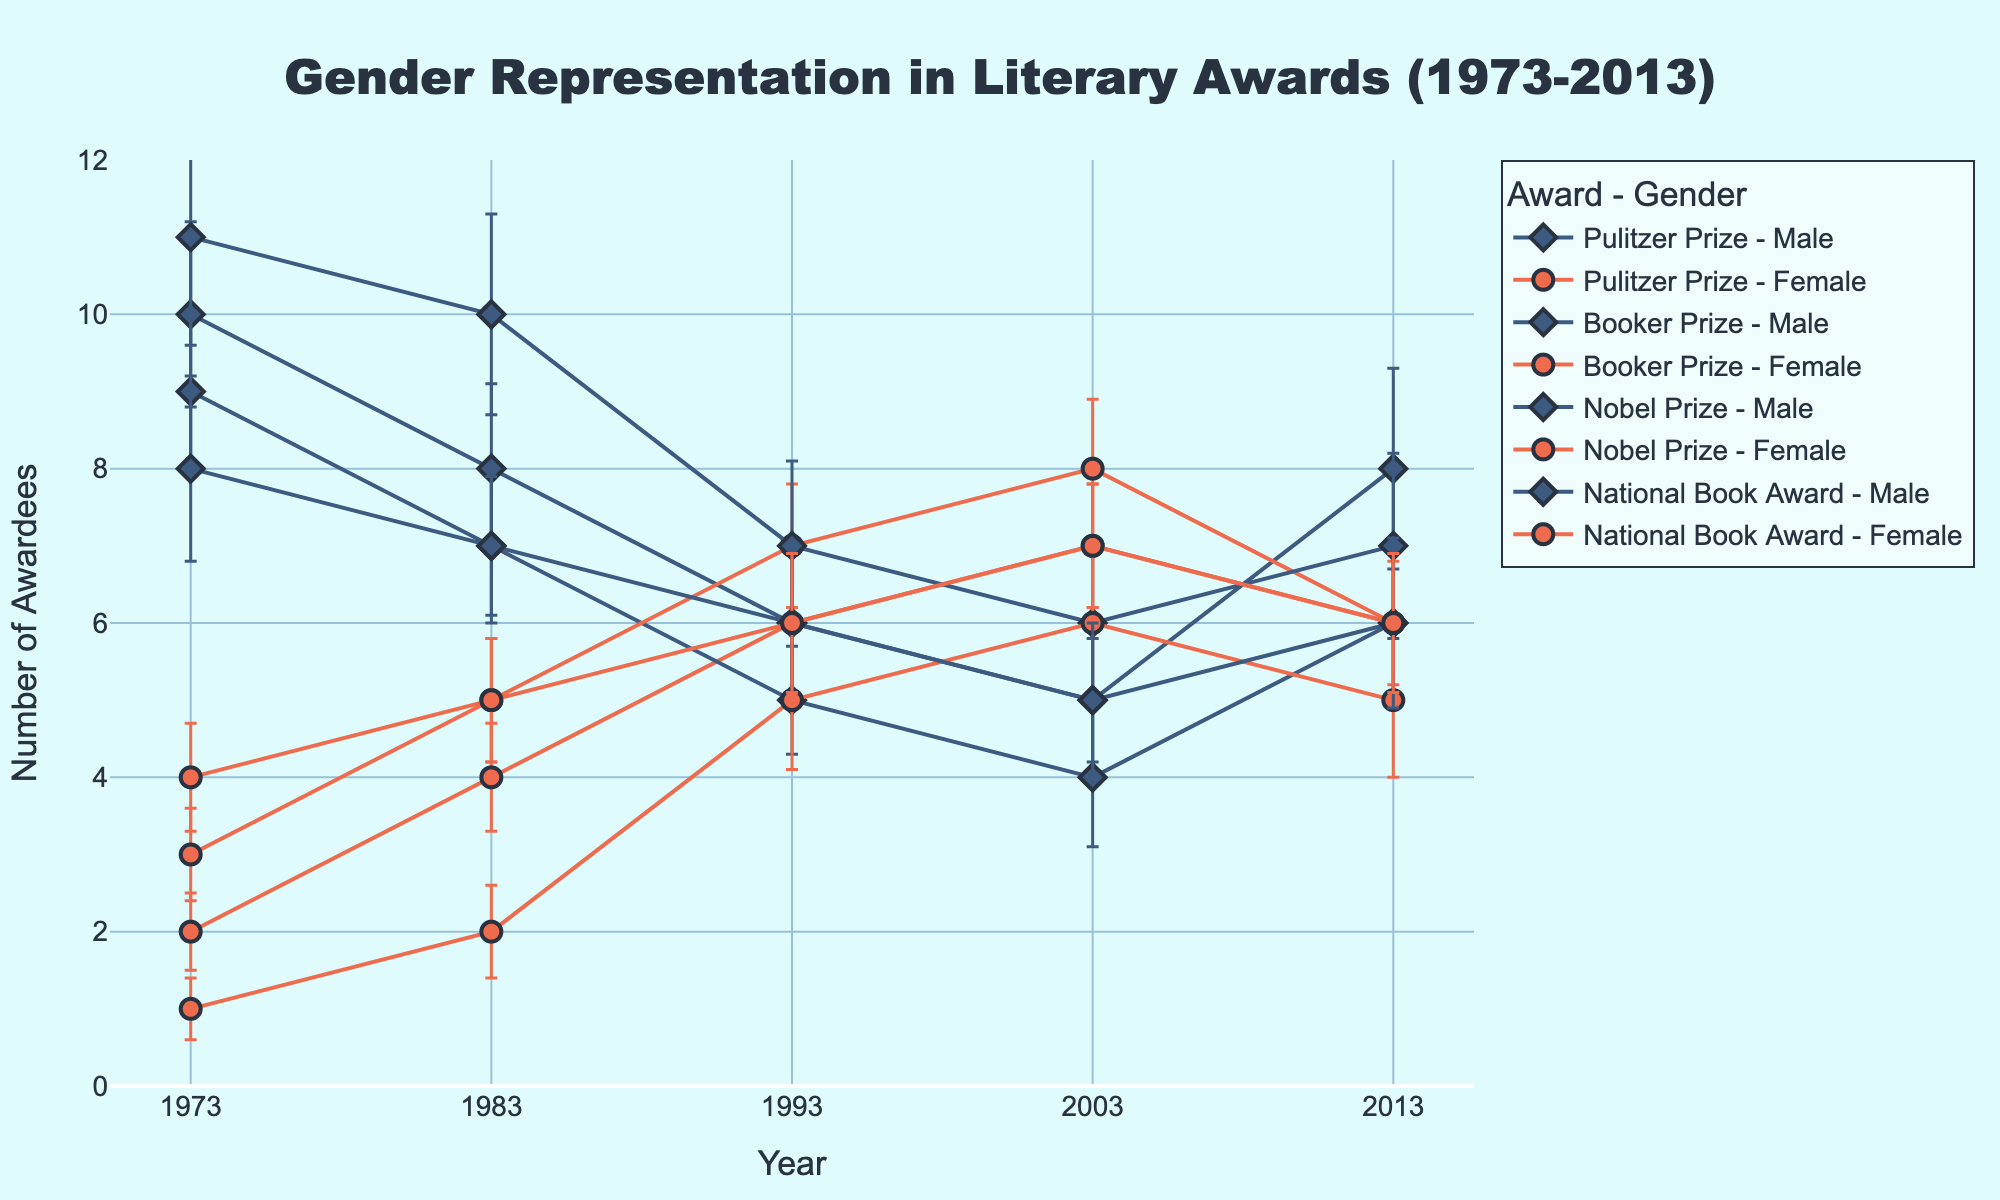What is the title of the figure? The title is generally located at the top of the figure and is intended to describe the content and purpose of the figure. The given figure's title describes the focus on gender representation within literary awards over a 40-year span.
Answer: Gender Representation in Literary Awards (1973-2013) How many different literary awards are represented in the figure? We can count the distinct award names listed in the legend or by looking at the information provided in the data. Each award will appear in both male and female categories.
Answer: 4 What is the color used to represent male awardees? Look for any legend or color labels that describe which colors correspond to each gender. Male awardees are represented with a particular color in the plot.
Answer: Blue In which year did female awardees receive the highest number of Booker Prize awards? Trace the lines or markers associated with the Booker Prize for females and look for the peak year where the value is highest.
Answer: 2003 What is the trend in the number of female Pulitzer Prize Fiction awardees from 1973 to 2013? Observe the line or markers associated with female Pulitzer Prize Fiction awardees across the years and describe the general direction (increasing, decreasing, or stable) of the line.
Answer: Increasing Which year shows an equal number of male and female Nobel Prize Literature awardees? Identify the points where the number of awardees for males and females in the Nobel Prize Literature category are the same across the years.
Answer: 2003 How does the variance in the number of female National Book Award Fiction awardees compare to male awardees in 1983? Compare the variance bars of the National Book Award Fiction for females and males in 1983 by observing their heights or lengths.
Answer: Female variance is lower than male variance In 2013, which award had the smallest difference in the number of male and female awardees? For each award in 2013, calculate the difference between the number of male and female awardees, and identify the award with the smallest calculated difference.
Answer: Booker Prize As of 1993, did the number of male awardees for the Nobel Prize in Literature increase or decrease compared to 1983? Compare the number of male awardees for the Nobel Prize in Literature between the years 1993 and 1983 by following the line or markers in the plot.
Answer: Decrease Which award had the largest average number of male awardees across all years? For each award, sum the number of male awardees across all years and then divide by the count of years to get the average. Identify the award with the highest average.
Answer: Nobel Prize 